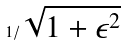<formula> <loc_0><loc_0><loc_500><loc_500>1 / \sqrt { 1 + \epsilon ^ { 2 } }</formula> 